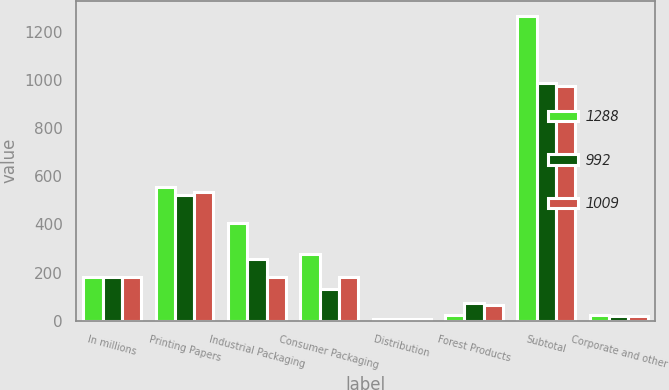<chart> <loc_0><loc_0><loc_500><loc_500><stacked_bar_chart><ecel><fcel>In millions<fcel>Printing Papers<fcel>Industrial Packaging<fcel>Consumer Packaging<fcel>Distribution<fcel>Forest Products<fcel>Subtotal<fcel>Corporate and other<nl><fcel>1288<fcel>180<fcel>556<fcel>405<fcel>276<fcel>6<fcel>22<fcel>1265<fcel>23<nl><fcel>992<fcel>180<fcel>523<fcel>257<fcel>130<fcel>6<fcel>72<fcel>988<fcel>21<nl><fcel>1009<fcel>180<fcel>536<fcel>180<fcel>182<fcel>9<fcel>66<fcel>973<fcel>19<nl></chart> 